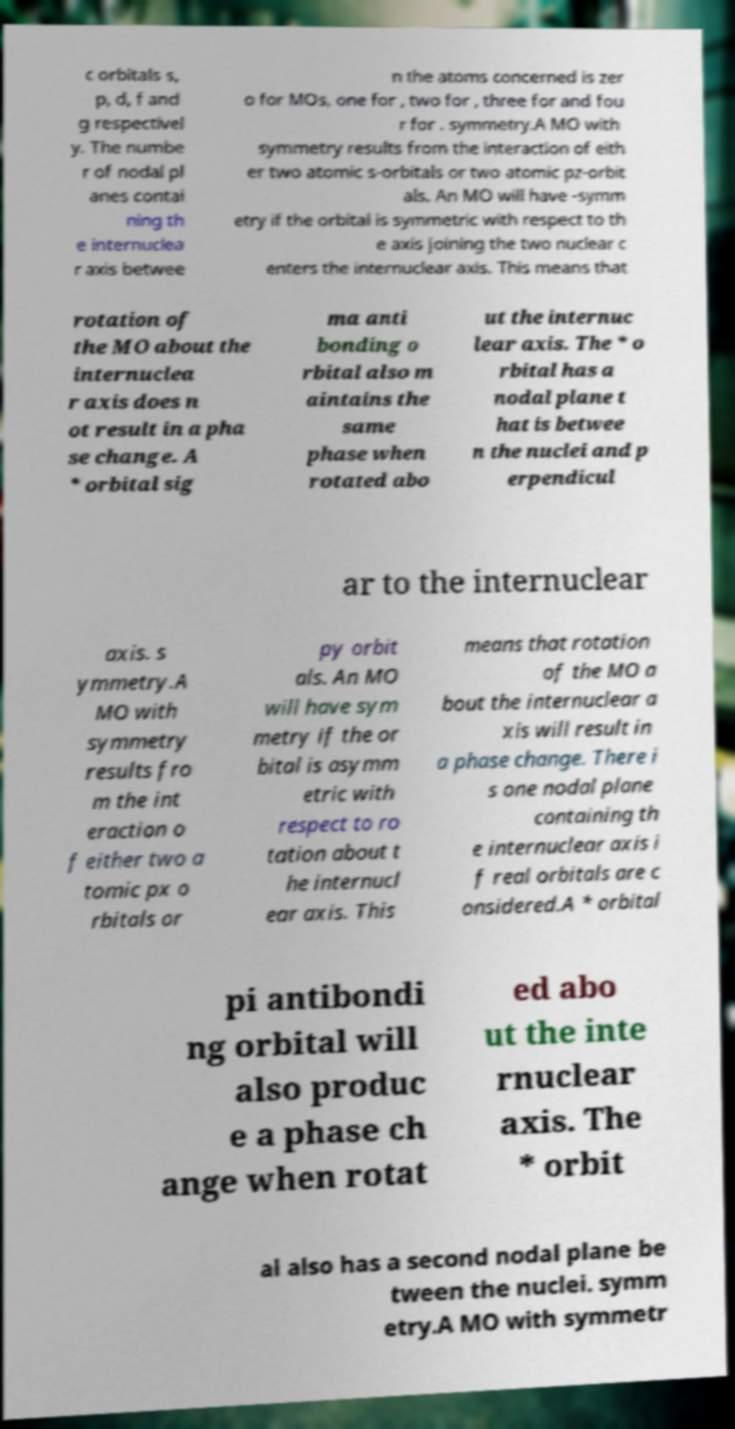What messages or text are displayed in this image? I need them in a readable, typed format. c orbitals s, p, d, f and g respectivel y. The numbe r of nodal pl anes contai ning th e internuclea r axis betwee n the atoms concerned is zer o for MOs, one for , two for , three for and fou r for . symmetry.A MO with symmetry results from the interaction of eith er two atomic s-orbitals or two atomic pz-orbit als. An MO will have -symm etry if the orbital is symmetric with respect to th e axis joining the two nuclear c enters the internuclear axis. This means that rotation of the MO about the internuclea r axis does n ot result in a pha se change. A * orbital sig ma anti bonding o rbital also m aintains the same phase when rotated abo ut the internuc lear axis. The * o rbital has a nodal plane t hat is betwee n the nuclei and p erpendicul ar to the internuclear axis. s ymmetry.A MO with symmetry results fro m the int eraction o f either two a tomic px o rbitals or py orbit als. An MO will have sym metry if the or bital is asymm etric with respect to ro tation about t he internucl ear axis. This means that rotation of the MO a bout the internuclear a xis will result in a phase change. There i s one nodal plane containing th e internuclear axis i f real orbitals are c onsidered.A * orbital pi antibondi ng orbital will also produc e a phase ch ange when rotat ed abo ut the inte rnuclear axis. The * orbit al also has a second nodal plane be tween the nuclei. symm etry.A MO with symmetr 